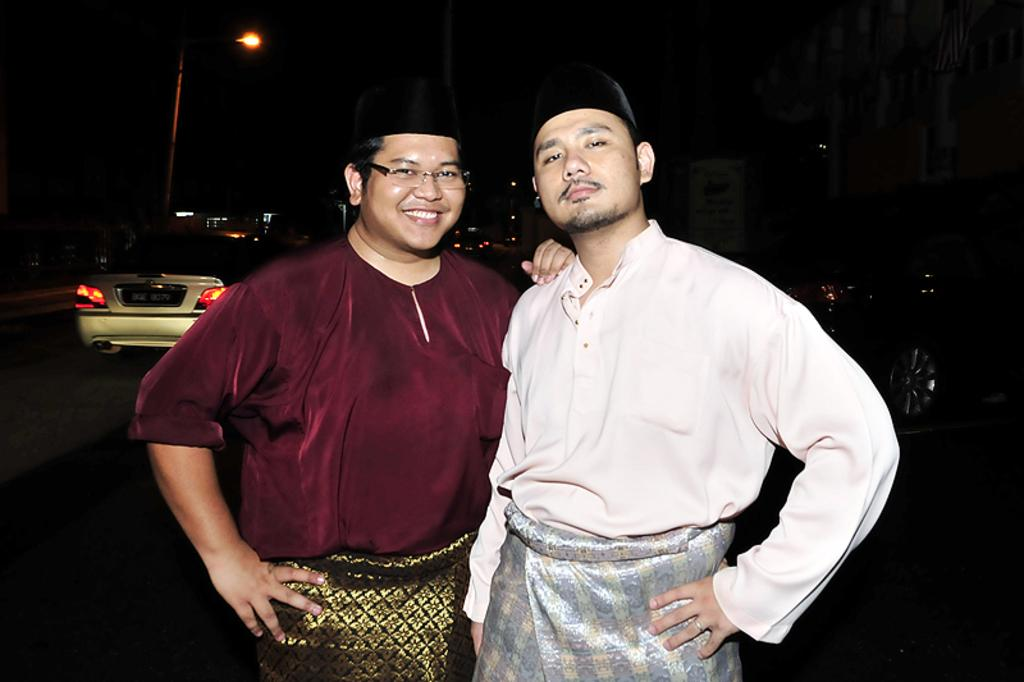What is happening in the center of the image? There are persons standing on the road in the center of the image. What can be seen in the background of the image? There is a car, a road, a street light, and buildings in the background of the image. What type of flower is being discussed by the persons standing on the road? There is no flower present in the image, nor is there any indication that the persons are discussing flowers. 